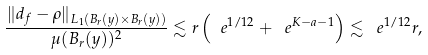Convert formula to latex. <formula><loc_0><loc_0><loc_500><loc_500>\frac { \| d _ { f } - \rho \| _ { L _ { 1 } ( B _ { r } ( y ) \times B _ { r } ( y ) ) } } { \mu ( B _ { r } ( y ) ) ^ { 2 } } \lesssim r \left ( \ e ^ { 1 / 1 2 } + \ e ^ { K - a - 1 } \right ) \lesssim \ e ^ { 1 / 1 2 } r ,</formula> 